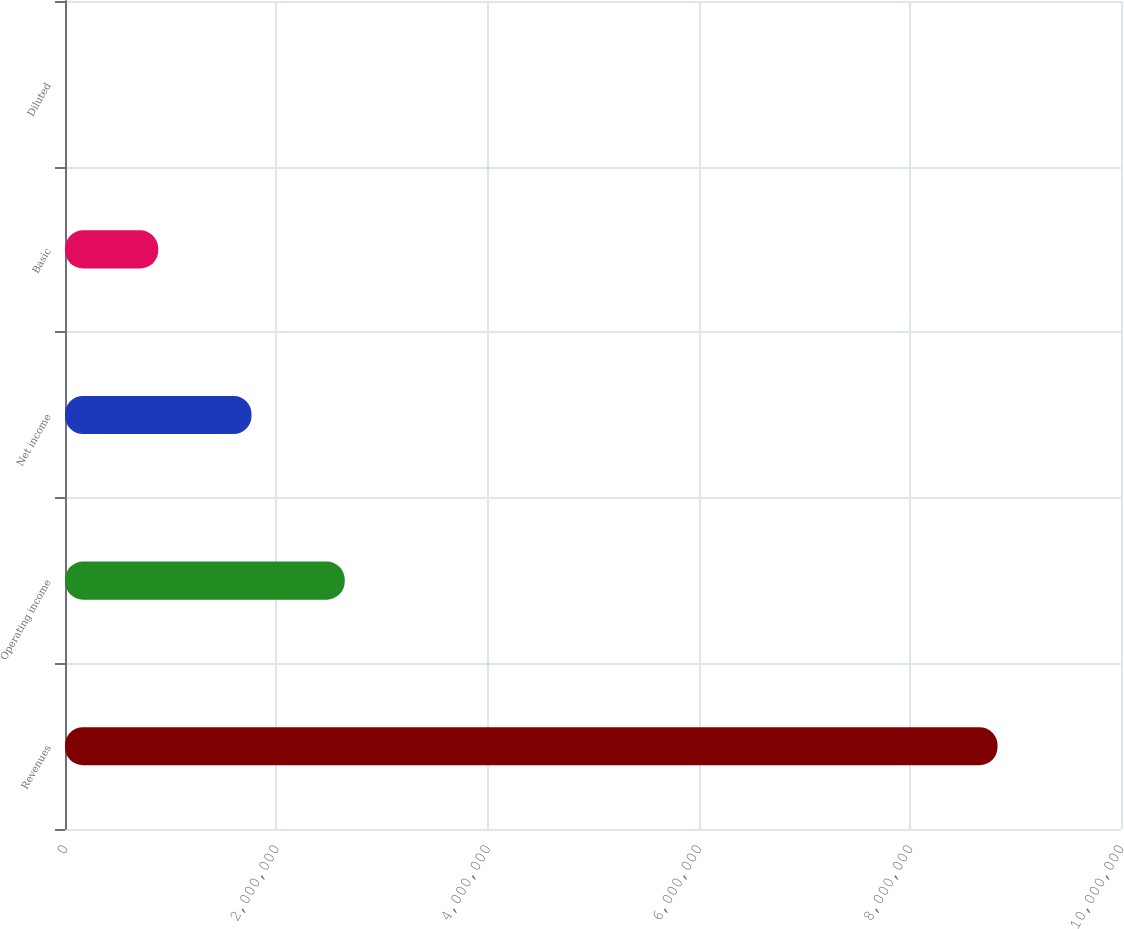Convert chart to OTSL. <chart><loc_0><loc_0><loc_500><loc_500><bar_chart><fcel>Revenues<fcel>Operating income<fcel>Net income<fcel>Basic<fcel>Diluted<nl><fcel>8.83067e+06<fcel>2.6492e+06<fcel>1.76613e+06<fcel>883067<fcel>0.43<nl></chart> 